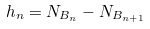Convert formula to latex. <formula><loc_0><loc_0><loc_500><loc_500>h _ { n } = N _ { B _ { n } } - N _ { B _ { n + 1 } }</formula> 